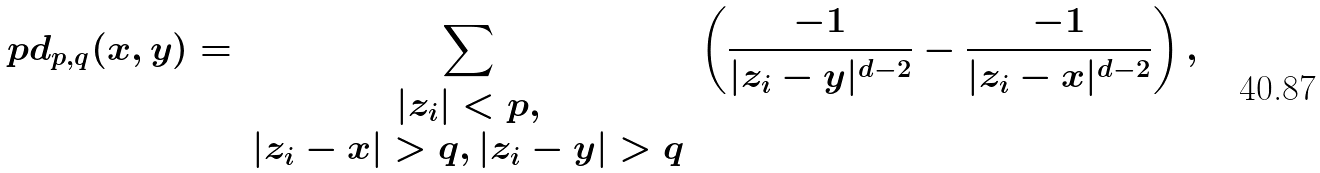Convert formula to latex. <formula><loc_0><loc_0><loc_500><loc_500>\ p d _ { p , q } ( x , y ) = \sum _ { \begin{array} { c } | z _ { i } | < p , \\ | z _ { i } - x | > q , | z _ { i } - y | > q \end{array} } \left ( \frac { - 1 } { | z _ { i } - y | ^ { d - 2 } } - \frac { - 1 } { | z _ { i } - x | ^ { d - 2 } } \right ) ,</formula> 